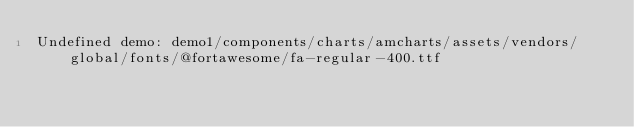<code> <loc_0><loc_0><loc_500><loc_500><_HTML_>Undefined demo: demo1/components/charts/amcharts/assets/vendors/global/fonts/@fortawesome/fa-regular-400.ttf</code> 